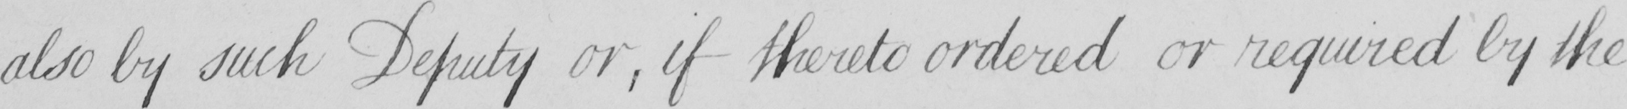Please transcribe the handwritten text in this image. also by such Deputy or , if thereto ordered or required by the 